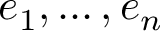Convert formula to latex. <formula><loc_0><loc_0><loc_500><loc_500>e _ { 1 } , \dots , e _ { n }</formula> 